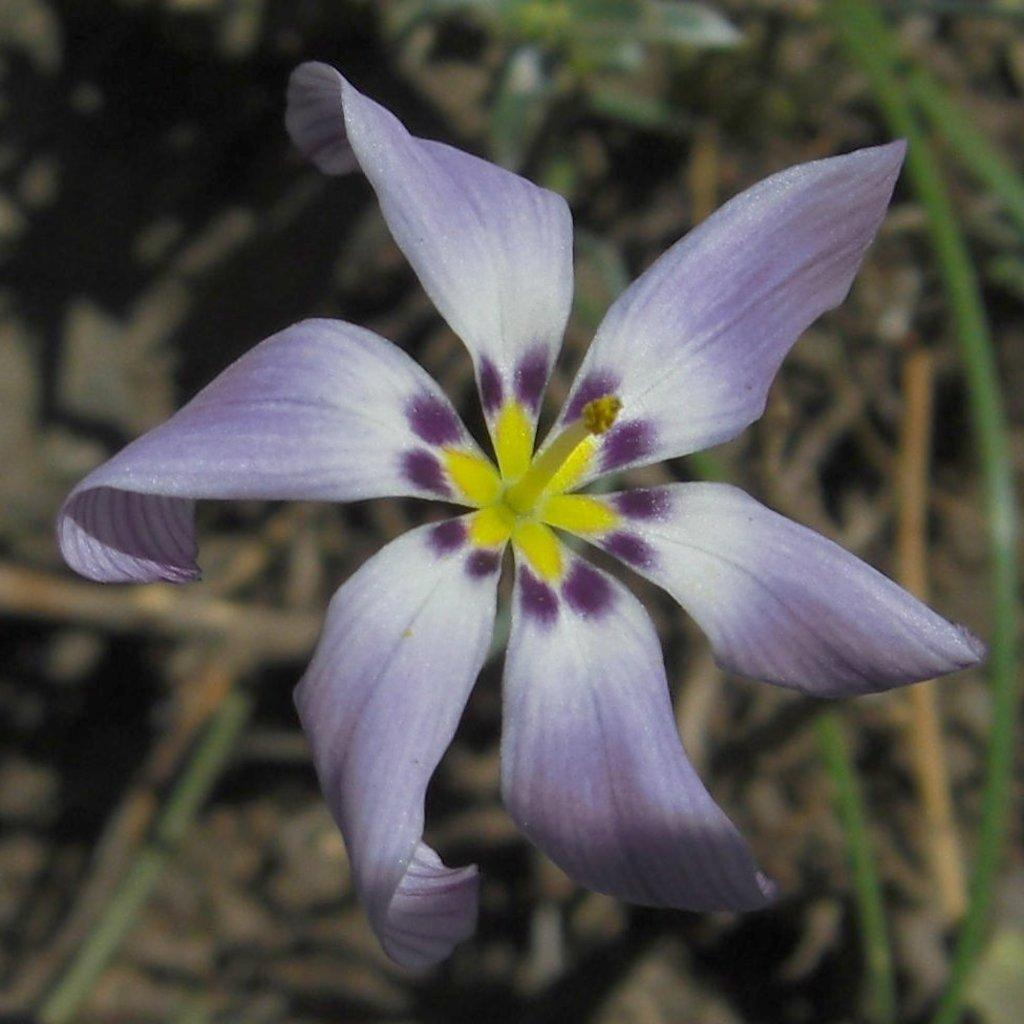What is the main subject of the picture? There is a flower in the picture. Can you describe the background of the image? The background of the image is blurred. What type of doctor is examining the window in the image? There is no doctor or window present in the image. 